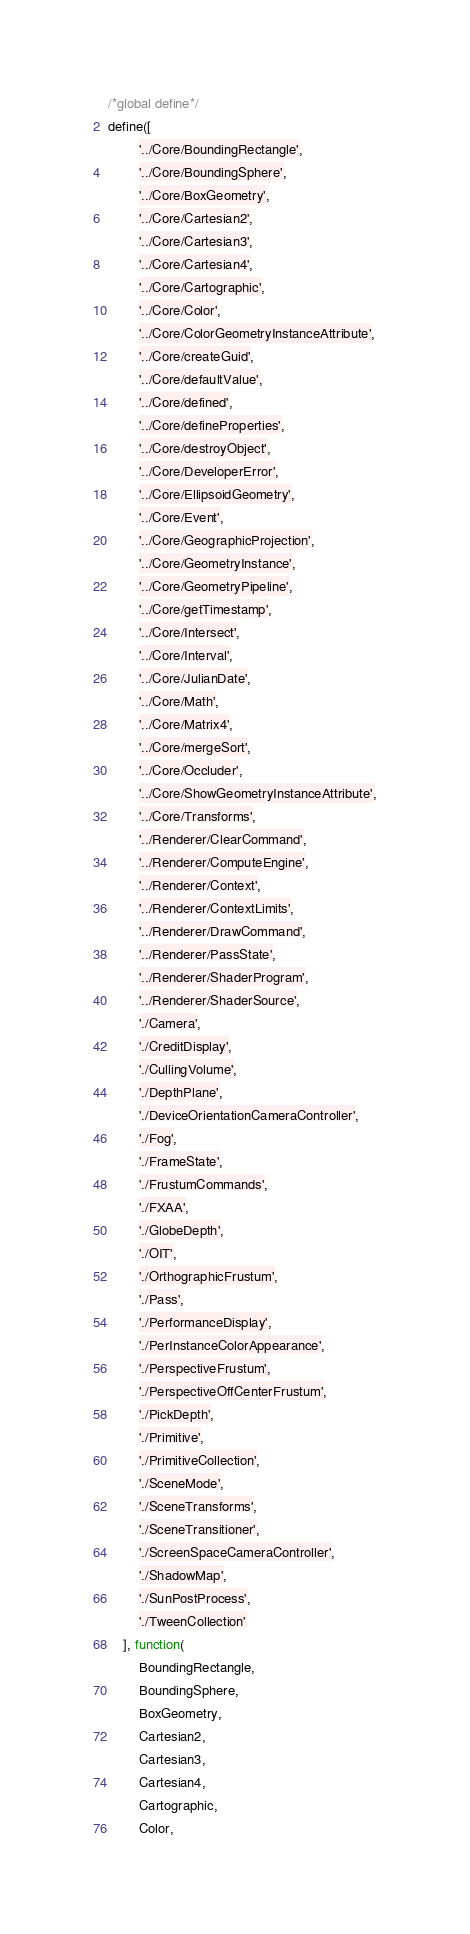Convert code to text. <code><loc_0><loc_0><loc_500><loc_500><_JavaScript_>/*global define*/
define([
        '../Core/BoundingRectangle',
        '../Core/BoundingSphere',
        '../Core/BoxGeometry',
        '../Core/Cartesian2',
        '../Core/Cartesian3',
        '../Core/Cartesian4',
        '../Core/Cartographic',
        '../Core/Color',
        '../Core/ColorGeometryInstanceAttribute',
        '../Core/createGuid',
        '../Core/defaultValue',
        '../Core/defined',
        '../Core/defineProperties',
        '../Core/destroyObject',
        '../Core/DeveloperError',
        '../Core/EllipsoidGeometry',
        '../Core/Event',
        '../Core/GeographicProjection',
        '../Core/GeometryInstance',
        '../Core/GeometryPipeline',
        '../Core/getTimestamp',
        '../Core/Intersect',
        '../Core/Interval',
        '../Core/JulianDate',
        '../Core/Math',
        '../Core/Matrix4',
        '../Core/mergeSort',
        '../Core/Occluder',
        '../Core/ShowGeometryInstanceAttribute',
        '../Core/Transforms',
        '../Renderer/ClearCommand',
        '../Renderer/ComputeEngine',
        '../Renderer/Context',
        '../Renderer/ContextLimits',
        '../Renderer/DrawCommand',
        '../Renderer/PassState',
        '../Renderer/ShaderProgram',
        '../Renderer/ShaderSource',
        './Camera',
        './CreditDisplay',
        './CullingVolume',
        './DepthPlane',
        './DeviceOrientationCameraController',
        './Fog',
        './FrameState',
        './FrustumCommands',
        './FXAA',
        './GlobeDepth',
        './OIT',
        './OrthographicFrustum',
        './Pass',
        './PerformanceDisplay',
        './PerInstanceColorAppearance',
        './PerspectiveFrustum',
        './PerspectiveOffCenterFrustum',
        './PickDepth',
        './Primitive',
        './PrimitiveCollection',
        './SceneMode',
        './SceneTransforms',
        './SceneTransitioner',
        './ScreenSpaceCameraController',
        './ShadowMap',
        './SunPostProcess',
        './TweenCollection'
    ], function(
        BoundingRectangle,
        BoundingSphere,
        BoxGeometry,
        Cartesian2,
        Cartesian3,
        Cartesian4,
        Cartographic,
        Color,</code> 